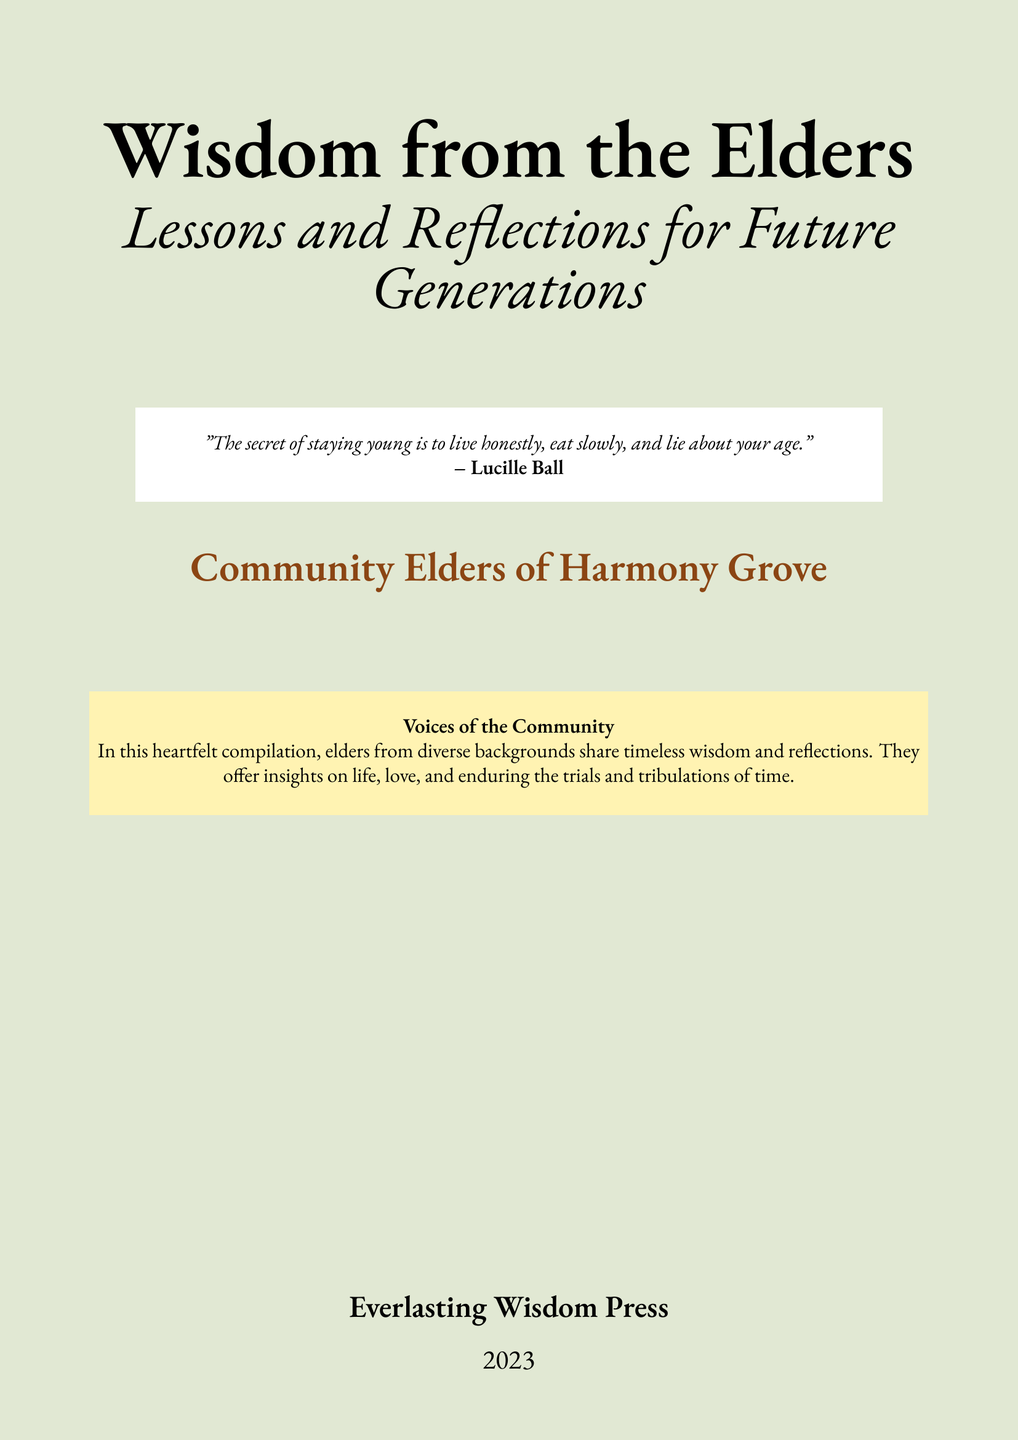What is the title of the book? The title of the book is prominently displayed at the top of the cover.
Answer: Wisdom from the Elders Who is the author of the book? The author is mentioned at the bottom of the cover under the community name.
Answer: Community Elders of Harmony Grove What year was the book published? The publication year is indicated at the bottom of the cover.
Answer: 2023 What color is the primary background of the cover? The primary background color is specified in the document as a color name.
Answer: Light green What quote is included on the book cover? The quote is presented in a highlighted section on the cover, attributed to a well-known figure.
Answer: "The secret of staying young is to live honestly, eat slowly, and lie about your age." What type of content does the book contain? The content type is described in a brief paragraph on the cover.
Answer: Timeless wisdom and reflections What is the subtitle of the book? The subtitle is presented directly below the main title and describes the book's content.
Answer: Lessons and Reflections for Future Generations What publishing house released the book? The name of the publishing house is at the bottom of the cover.
Answer: Everlasting Wisdom Press What theme is highlighted by the community elders? The theme is expressed in a short paragraph that describes the nature of the elders' contributions.
Answer: Voices of the Community 